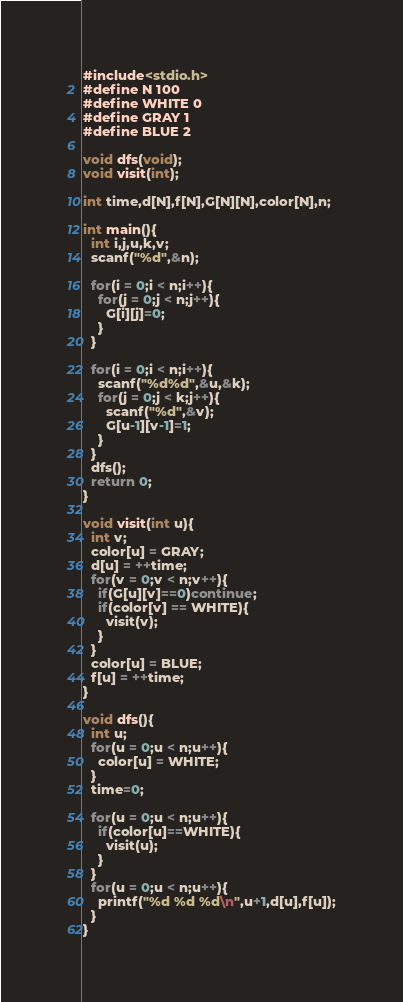Convert code to text. <code><loc_0><loc_0><loc_500><loc_500><_C_>#include<stdio.h>
#define N 100
#define WHITE 0
#define GRAY 1
#define BLUE 2

void dfs(void);
void visit(int);

int time,d[N],f[N],G[N][N],color[N],n;

int main(){
  int i,j,u,k,v;
  scanf("%d",&n);

  for(i = 0;i < n;i++){
    for(j = 0;j < n;j++){
      G[i][j]=0;
    }
  }

  for(i = 0;i < n;i++){
    scanf("%d%d",&u,&k);
    for(j = 0;j < k;j++){
      scanf("%d",&v);
      G[u-1][v-1]=1;
    }
  }
  dfs();
  return 0;
}

void visit(int u){
  int v;
  color[u] = GRAY;
  d[u] = ++time;
  for(v = 0;v < n;v++){
    if(G[u][v]==0)continue;
    if(color[v] == WHITE){
      visit(v);
    }
  }
  color[u] = BLUE;
  f[u] = ++time;
}

void dfs(){
  int u;
  for(u = 0;u < n;u++){
    color[u] = WHITE;
  }
  time=0;

  for(u = 0;u < n;u++){
    if(color[u]==WHITE){
      visit(u);
    }
  }
  for(u = 0;u < n;u++){
    printf("%d %d %d\n",u+1,d[u],f[u]);
  }
}</code> 